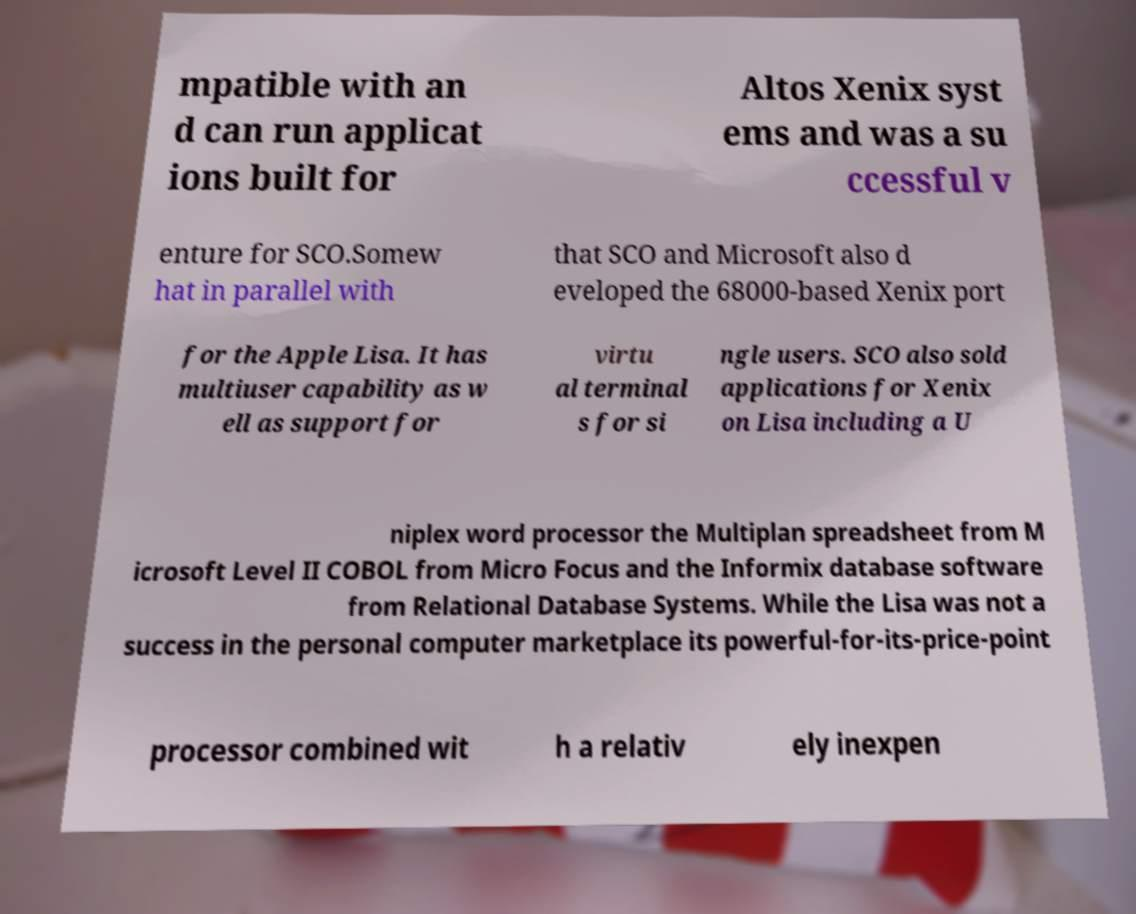What messages or text are displayed in this image? I need them in a readable, typed format. mpatible with an d can run applicat ions built for Altos Xenix syst ems and was a su ccessful v enture for SCO.Somew hat in parallel with that SCO and Microsoft also d eveloped the 68000-based Xenix port for the Apple Lisa. It has multiuser capability as w ell as support for virtu al terminal s for si ngle users. SCO also sold applications for Xenix on Lisa including a U niplex word processor the Multiplan spreadsheet from M icrosoft Level II COBOL from Micro Focus and the Informix database software from Relational Database Systems. While the Lisa was not a success in the personal computer marketplace its powerful-for-its-price-point processor combined wit h a relativ ely inexpen 